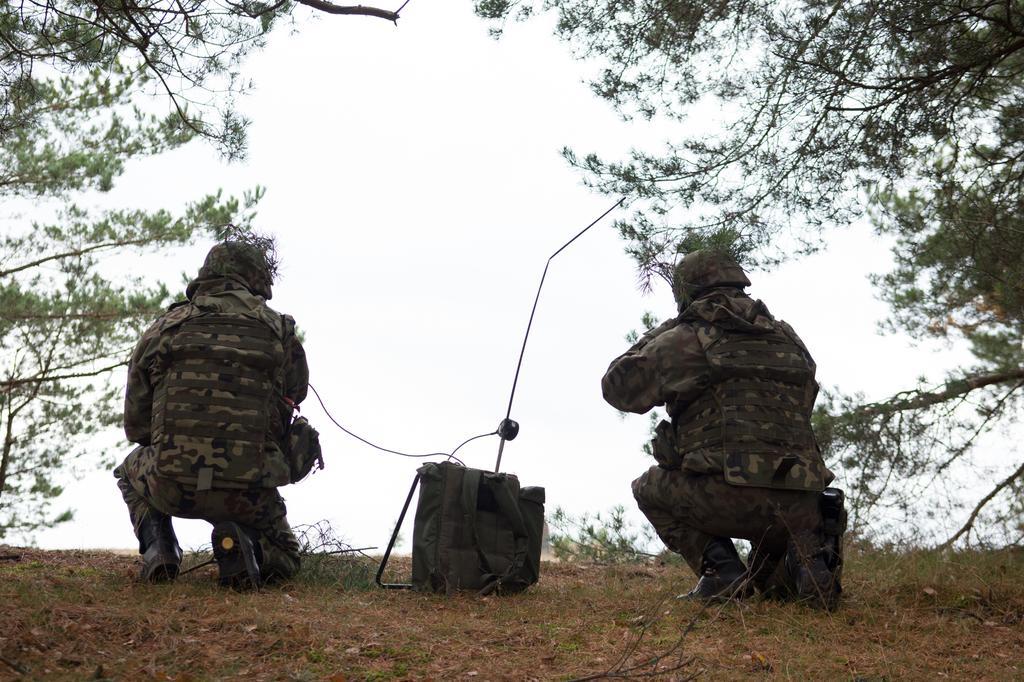How would you summarize this image in a sentence or two? In the image there are two soldiers and there is a bag in between them, around the soldiers there are many branches of trees. 